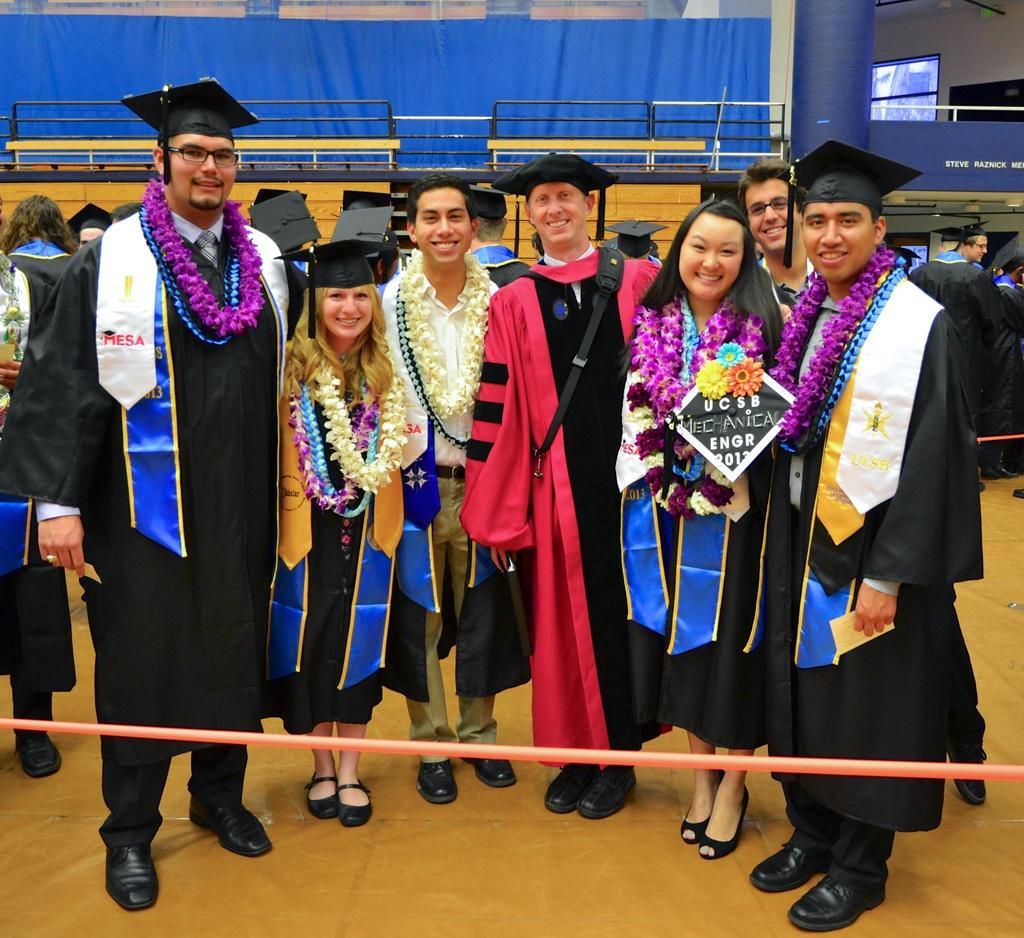In one or two sentences, can you explain what this image depicts? This image is taken during the convocation time. In this image we can see the men and women standing on the floor and smiling. We can also see a few people wearing the garland. In the background we can see the persons. We can also see the blue color curtain, screen, fence. At the bottom we can see some tube. 